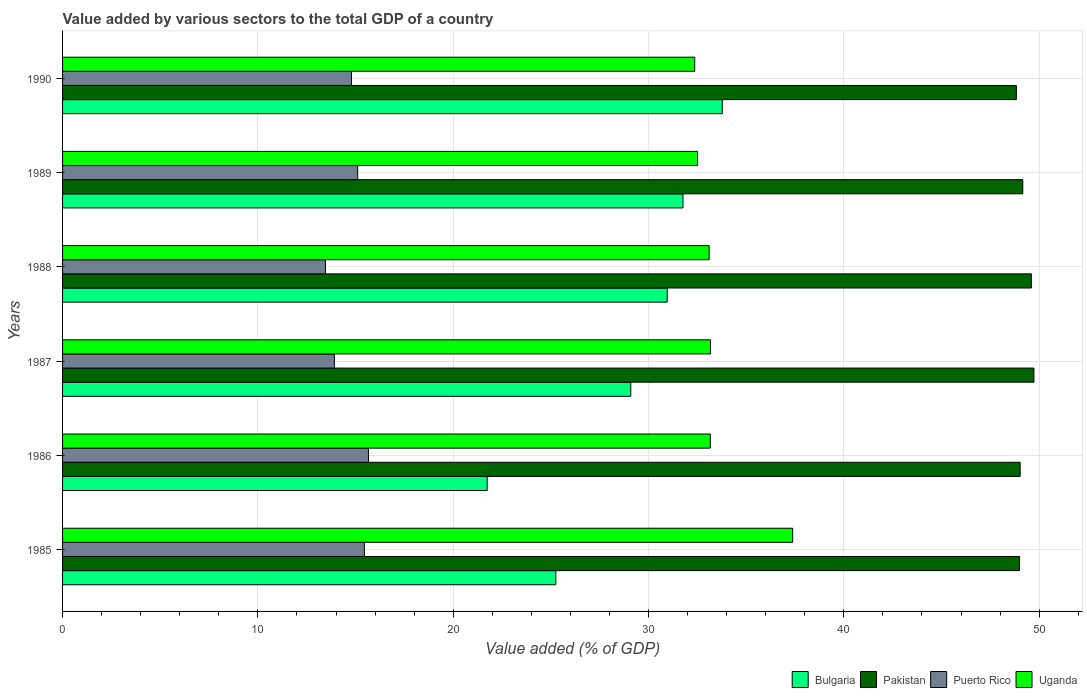How many different coloured bars are there?
Provide a succinct answer. 4. How many groups of bars are there?
Give a very brief answer. 6. Are the number of bars per tick equal to the number of legend labels?
Provide a short and direct response. Yes. Are the number of bars on each tick of the Y-axis equal?
Provide a short and direct response. Yes. How many bars are there on the 3rd tick from the top?
Offer a very short reply. 4. What is the label of the 6th group of bars from the top?
Provide a succinct answer. 1985. What is the value added by various sectors to the total GDP in Bulgaria in 1985?
Keep it short and to the point. 25.25. Across all years, what is the maximum value added by various sectors to the total GDP in Puerto Rico?
Provide a short and direct response. 15.66. Across all years, what is the minimum value added by various sectors to the total GDP in Bulgaria?
Provide a succinct answer. 21.74. In which year was the value added by various sectors to the total GDP in Puerto Rico maximum?
Your answer should be compact. 1986. What is the total value added by various sectors to the total GDP in Uganda in the graph?
Provide a succinct answer. 201.69. What is the difference between the value added by various sectors to the total GDP in Pakistan in 1986 and that in 1990?
Keep it short and to the point. 0.19. What is the difference between the value added by various sectors to the total GDP in Bulgaria in 1990 and the value added by various sectors to the total GDP in Pakistan in 1985?
Provide a succinct answer. -15.22. What is the average value added by various sectors to the total GDP in Pakistan per year?
Your answer should be very brief. 49.22. In the year 1986, what is the difference between the value added by various sectors to the total GDP in Bulgaria and value added by various sectors to the total GDP in Puerto Rico?
Make the answer very short. 6.08. In how many years, is the value added by various sectors to the total GDP in Puerto Rico greater than 26 %?
Provide a short and direct response. 0. What is the ratio of the value added by various sectors to the total GDP in Bulgaria in 1988 to that in 1990?
Provide a succinct answer. 0.92. Is the difference between the value added by various sectors to the total GDP in Bulgaria in 1986 and 1988 greater than the difference between the value added by various sectors to the total GDP in Puerto Rico in 1986 and 1988?
Ensure brevity in your answer.  No. What is the difference between the highest and the second highest value added by various sectors to the total GDP in Puerto Rico?
Offer a terse response. 0.21. What is the difference between the highest and the lowest value added by various sectors to the total GDP in Uganda?
Keep it short and to the point. 5.01. In how many years, is the value added by various sectors to the total GDP in Pakistan greater than the average value added by various sectors to the total GDP in Pakistan taken over all years?
Ensure brevity in your answer.  2. Is it the case that in every year, the sum of the value added by various sectors to the total GDP in Uganda and value added by various sectors to the total GDP in Pakistan is greater than the sum of value added by various sectors to the total GDP in Puerto Rico and value added by various sectors to the total GDP in Bulgaria?
Ensure brevity in your answer.  Yes. What does the 4th bar from the top in 1990 represents?
Your response must be concise. Bulgaria. What does the 2nd bar from the bottom in 1987 represents?
Offer a terse response. Pakistan. Is it the case that in every year, the sum of the value added by various sectors to the total GDP in Bulgaria and value added by various sectors to the total GDP in Uganda is greater than the value added by various sectors to the total GDP in Pakistan?
Provide a short and direct response. Yes. How many bars are there?
Your answer should be very brief. 24. How many years are there in the graph?
Make the answer very short. 6. What is the difference between two consecutive major ticks on the X-axis?
Your answer should be very brief. 10. Are the values on the major ticks of X-axis written in scientific E-notation?
Your answer should be very brief. No. Does the graph contain any zero values?
Your answer should be compact. No. What is the title of the graph?
Your response must be concise. Value added by various sectors to the total GDP of a country. What is the label or title of the X-axis?
Provide a short and direct response. Value added (% of GDP). What is the Value added (% of GDP) of Bulgaria in 1985?
Your answer should be compact. 25.25. What is the Value added (% of GDP) in Pakistan in 1985?
Your answer should be compact. 49. What is the Value added (% of GDP) of Puerto Rico in 1985?
Make the answer very short. 15.45. What is the Value added (% of GDP) in Uganda in 1985?
Your answer should be very brief. 37.38. What is the Value added (% of GDP) in Bulgaria in 1986?
Provide a short and direct response. 21.74. What is the Value added (% of GDP) in Pakistan in 1986?
Your response must be concise. 49.03. What is the Value added (% of GDP) of Puerto Rico in 1986?
Offer a terse response. 15.66. What is the Value added (% of GDP) of Uganda in 1986?
Keep it short and to the point. 33.16. What is the Value added (% of GDP) in Bulgaria in 1987?
Offer a very short reply. 29.09. What is the Value added (% of GDP) in Pakistan in 1987?
Provide a succinct answer. 49.73. What is the Value added (% of GDP) in Puerto Rico in 1987?
Provide a short and direct response. 13.92. What is the Value added (% of GDP) in Uganda in 1987?
Offer a very short reply. 33.17. What is the Value added (% of GDP) in Bulgaria in 1988?
Provide a succinct answer. 30.96. What is the Value added (% of GDP) of Pakistan in 1988?
Ensure brevity in your answer.  49.6. What is the Value added (% of GDP) in Puerto Rico in 1988?
Keep it short and to the point. 13.46. What is the Value added (% of GDP) of Uganda in 1988?
Provide a succinct answer. 33.1. What is the Value added (% of GDP) of Bulgaria in 1989?
Provide a succinct answer. 31.76. What is the Value added (% of GDP) in Pakistan in 1989?
Your response must be concise. 49.16. What is the Value added (% of GDP) of Puerto Rico in 1989?
Make the answer very short. 15.11. What is the Value added (% of GDP) in Uganda in 1989?
Ensure brevity in your answer.  32.51. What is the Value added (% of GDP) in Bulgaria in 1990?
Your response must be concise. 33.78. What is the Value added (% of GDP) in Pakistan in 1990?
Your answer should be very brief. 48.83. What is the Value added (% of GDP) in Puerto Rico in 1990?
Make the answer very short. 14.79. What is the Value added (% of GDP) in Uganda in 1990?
Offer a terse response. 32.36. Across all years, what is the maximum Value added (% of GDP) in Bulgaria?
Keep it short and to the point. 33.78. Across all years, what is the maximum Value added (% of GDP) in Pakistan?
Offer a terse response. 49.73. Across all years, what is the maximum Value added (% of GDP) of Puerto Rico?
Make the answer very short. 15.66. Across all years, what is the maximum Value added (% of GDP) of Uganda?
Your response must be concise. 37.38. Across all years, what is the minimum Value added (% of GDP) of Bulgaria?
Offer a terse response. 21.74. Across all years, what is the minimum Value added (% of GDP) in Pakistan?
Make the answer very short. 48.83. Across all years, what is the minimum Value added (% of GDP) of Puerto Rico?
Offer a terse response. 13.46. Across all years, what is the minimum Value added (% of GDP) of Uganda?
Ensure brevity in your answer.  32.36. What is the total Value added (% of GDP) of Bulgaria in the graph?
Ensure brevity in your answer.  172.59. What is the total Value added (% of GDP) in Pakistan in the graph?
Offer a very short reply. 295.35. What is the total Value added (% of GDP) in Puerto Rico in the graph?
Your answer should be compact. 88.39. What is the total Value added (% of GDP) in Uganda in the graph?
Provide a succinct answer. 201.69. What is the difference between the Value added (% of GDP) in Bulgaria in 1985 and that in 1986?
Your answer should be compact. 3.51. What is the difference between the Value added (% of GDP) of Pakistan in 1985 and that in 1986?
Give a very brief answer. -0.03. What is the difference between the Value added (% of GDP) of Puerto Rico in 1985 and that in 1986?
Keep it short and to the point. -0.21. What is the difference between the Value added (% of GDP) in Uganda in 1985 and that in 1986?
Your response must be concise. 4.22. What is the difference between the Value added (% of GDP) in Bulgaria in 1985 and that in 1987?
Provide a short and direct response. -3.84. What is the difference between the Value added (% of GDP) in Pakistan in 1985 and that in 1987?
Give a very brief answer. -0.74. What is the difference between the Value added (% of GDP) in Puerto Rico in 1985 and that in 1987?
Your response must be concise. 1.54. What is the difference between the Value added (% of GDP) in Uganda in 1985 and that in 1987?
Ensure brevity in your answer.  4.21. What is the difference between the Value added (% of GDP) in Bulgaria in 1985 and that in 1988?
Provide a short and direct response. -5.7. What is the difference between the Value added (% of GDP) of Pakistan in 1985 and that in 1988?
Your response must be concise. -0.61. What is the difference between the Value added (% of GDP) in Puerto Rico in 1985 and that in 1988?
Provide a succinct answer. 1.99. What is the difference between the Value added (% of GDP) in Uganda in 1985 and that in 1988?
Provide a short and direct response. 4.28. What is the difference between the Value added (% of GDP) in Bulgaria in 1985 and that in 1989?
Keep it short and to the point. -6.51. What is the difference between the Value added (% of GDP) of Pakistan in 1985 and that in 1989?
Provide a short and direct response. -0.17. What is the difference between the Value added (% of GDP) in Puerto Rico in 1985 and that in 1989?
Your response must be concise. 0.34. What is the difference between the Value added (% of GDP) of Uganda in 1985 and that in 1989?
Provide a short and direct response. 4.87. What is the difference between the Value added (% of GDP) of Bulgaria in 1985 and that in 1990?
Your response must be concise. -8.52. What is the difference between the Value added (% of GDP) of Pakistan in 1985 and that in 1990?
Offer a very short reply. 0.16. What is the difference between the Value added (% of GDP) in Puerto Rico in 1985 and that in 1990?
Ensure brevity in your answer.  0.66. What is the difference between the Value added (% of GDP) in Uganda in 1985 and that in 1990?
Your response must be concise. 5.01. What is the difference between the Value added (% of GDP) in Bulgaria in 1986 and that in 1987?
Offer a terse response. -7.35. What is the difference between the Value added (% of GDP) in Pakistan in 1986 and that in 1987?
Provide a succinct answer. -0.71. What is the difference between the Value added (% of GDP) in Puerto Rico in 1986 and that in 1987?
Make the answer very short. 1.74. What is the difference between the Value added (% of GDP) in Uganda in 1986 and that in 1987?
Your answer should be compact. -0.01. What is the difference between the Value added (% of GDP) of Bulgaria in 1986 and that in 1988?
Provide a short and direct response. -9.22. What is the difference between the Value added (% of GDP) in Pakistan in 1986 and that in 1988?
Your response must be concise. -0.58. What is the difference between the Value added (% of GDP) of Puerto Rico in 1986 and that in 1988?
Offer a terse response. 2.2. What is the difference between the Value added (% of GDP) in Uganda in 1986 and that in 1988?
Make the answer very short. 0.06. What is the difference between the Value added (% of GDP) in Bulgaria in 1986 and that in 1989?
Ensure brevity in your answer.  -10.02. What is the difference between the Value added (% of GDP) in Pakistan in 1986 and that in 1989?
Provide a succinct answer. -0.13. What is the difference between the Value added (% of GDP) of Puerto Rico in 1986 and that in 1989?
Keep it short and to the point. 0.55. What is the difference between the Value added (% of GDP) of Uganda in 1986 and that in 1989?
Your answer should be compact. 0.65. What is the difference between the Value added (% of GDP) of Bulgaria in 1986 and that in 1990?
Your response must be concise. -12.04. What is the difference between the Value added (% of GDP) in Pakistan in 1986 and that in 1990?
Your answer should be very brief. 0.19. What is the difference between the Value added (% of GDP) of Puerto Rico in 1986 and that in 1990?
Give a very brief answer. 0.87. What is the difference between the Value added (% of GDP) of Uganda in 1986 and that in 1990?
Your answer should be very brief. 0.8. What is the difference between the Value added (% of GDP) of Bulgaria in 1987 and that in 1988?
Your answer should be very brief. -1.87. What is the difference between the Value added (% of GDP) in Pakistan in 1987 and that in 1988?
Ensure brevity in your answer.  0.13. What is the difference between the Value added (% of GDP) in Puerto Rico in 1987 and that in 1988?
Provide a succinct answer. 0.46. What is the difference between the Value added (% of GDP) in Uganda in 1987 and that in 1988?
Offer a terse response. 0.07. What is the difference between the Value added (% of GDP) of Bulgaria in 1987 and that in 1989?
Keep it short and to the point. -2.67. What is the difference between the Value added (% of GDP) of Pakistan in 1987 and that in 1989?
Offer a very short reply. 0.57. What is the difference between the Value added (% of GDP) of Puerto Rico in 1987 and that in 1989?
Give a very brief answer. -1.19. What is the difference between the Value added (% of GDP) of Uganda in 1987 and that in 1989?
Your answer should be very brief. 0.66. What is the difference between the Value added (% of GDP) of Bulgaria in 1987 and that in 1990?
Keep it short and to the point. -4.68. What is the difference between the Value added (% of GDP) in Pakistan in 1987 and that in 1990?
Your answer should be very brief. 0.9. What is the difference between the Value added (% of GDP) in Puerto Rico in 1987 and that in 1990?
Provide a short and direct response. -0.88. What is the difference between the Value added (% of GDP) in Uganda in 1987 and that in 1990?
Your answer should be very brief. 0.8. What is the difference between the Value added (% of GDP) in Bulgaria in 1988 and that in 1989?
Your response must be concise. -0.81. What is the difference between the Value added (% of GDP) in Pakistan in 1988 and that in 1989?
Provide a succinct answer. 0.44. What is the difference between the Value added (% of GDP) in Puerto Rico in 1988 and that in 1989?
Provide a succinct answer. -1.65. What is the difference between the Value added (% of GDP) in Uganda in 1988 and that in 1989?
Offer a very short reply. 0.59. What is the difference between the Value added (% of GDP) of Bulgaria in 1988 and that in 1990?
Your response must be concise. -2.82. What is the difference between the Value added (% of GDP) of Pakistan in 1988 and that in 1990?
Give a very brief answer. 0.77. What is the difference between the Value added (% of GDP) of Puerto Rico in 1988 and that in 1990?
Ensure brevity in your answer.  -1.33. What is the difference between the Value added (% of GDP) in Uganda in 1988 and that in 1990?
Keep it short and to the point. 0.74. What is the difference between the Value added (% of GDP) of Bulgaria in 1989 and that in 1990?
Make the answer very short. -2.01. What is the difference between the Value added (% of GDP) in Pakistan in 1989 and that in 1990?
Ensure brevity in your answer.  0.33. What is the difference between the Value added (% of GDP) in Puerto Rico in 1989 and that in 1990?
Offer a terse response. 0.32. What is the difference between the Value added (% of GDP) of Uganda in 1989 and that in 1990?
Give a very brief answer. 0.15. What is the difference between the Value added (% of GDP) of Bulgaria in 1985 and the Value added (% of GDP) of Pakistan in 1986?
Provide a succinct answer. -23.77. What is the difference between the Value added (% of GDP) in Bulgaria in 1985 and the Value added (% of GDP) in Puerto Rico in 1986?
Ensure brevity in your answer.  9.59. What is the difference between the Value added (% of GDP) in Bulgaria in 1985 and the Value added (% of GDP) in Uganda in 1986?
Your response must be concise. -7.91. What is the difference between the Value added (% of GDP) in Pakistan in 1985 and the Value added (% of GDP) in Puerto Rico in 1986?
Offer a very short reply. 33.34. What is the difference between the Value added (% of GDP) of Pakistan in 1985 and the Value added (% of GDP) of Uganda in 1986?
Offer a terse response. 15.83. What is the difference between the Value added (% of GDP) of Puerto Rico in 1985 and the Value added (% of GDP) of Uganda in 1986?
Offer a very short reply. -17.71. What is the difference between the Value added (% of GDP) in Bulgaria in 1985 and the Value added (% of GDP) in Pakistan in 1987?
Keep it short and to the point. -24.48. What is the difference between the Value added (% of GDP) of Bulgaria in 1985 and the Value added (% of GDP) of Puerto Rico in 1987?
Your answer should be compact. 11.34. What is the difference between the Value added (% of GDP) in Bulgaria in 1985 and the Value added (% of GDP) in Uganda in 1987?
Your answer should be compact. -7.92. What is the difference between the Value added (% of GDP) in Pakistan in 1985 and the Value added (% of GDP) in Puerto Rico in 1987?
Give a very brief answer. 35.08. What is the difference between the Value added (% of GDP) in Pakistan in 1985 and the Value added (% of GDP) in Uganda in 1987?
Provide a short and direct response. 15.83. What is the difference between the Value added (% of GDP) in Puerto Rico in 1985 and the Value added (% of GDP) in Uganda in 1987?
Offer a terse response. -17.72. What is the difference between the Value added (% of GDP) of Bulgaria in 1985 and the Value added (% of GDP) of Pakistan in 1988?
Provide a succinct answer. -24.35. What is the difference between the Value added (% of GDP) in Bulgaria in 1985 and the Value added (% of GDP) in Puerto Rico in 1988?
Make the answer very short. 11.8. What is the difference between the Value added (% of GDP) of Bulgaria in 1985 and the Value added (% of GDP) of Uganda in 1988?
Give a very brief answer. -7.85. What is the difference between the Value added (% of GDP) of Pakistan in 1985 and the Value added (% of GDP) of Puerto Rico in 1988?
Ensure brevity in your answer.  35.54. What is the difference between the Value added (% of GDP) in Pakistan in 1985 and the Value added (% of GDP) in Uganda in 1988?
Give a very brief answer. 15.89. What is the difference between the Value added (% of GDP) of Puerto Rico in 1985 and the Value added (% of GDP) of Uganda in 1988?
Offer a terse response. -17.65. What is the difference between the Value added (% of GDP) of Bulgaria in 1985 and the Value added (% of GDP) of Pakistan in 1989?
Ensure brevity in your answer.  -23.91. What is the difference between the Value added (% of GDP) in Bulgaria in 1985 and the Value added (% of GDP) in Puerto Rico in 1989?
Provide a short and direct response. 10.15. What is the difference between the Value added (% of GDP) of Bulgaria in 1985 and the Value added (% of GDP) of Uganda in 1989?
Your response must be concise. -7.26. What is the difference between the Value added (% of GDP) in Pakistan in 1985 and the Value added (% of GDP) in Puerto Rico in 1989?
Give a very brief answer. 33.89. What is the difference between the Value added (% of GDP) of Pakistan in 1985 and the Value added (% of GDP) of Uganda in 1989?
Your response must be concise. 16.49. What is the difference between the Value added (% of GDP) in Puerto Rico in 1985 and the Value added (% of GDP) in Uganda in 1989?
Provide a succinct answer. -17.06. What is the difference between the Value added (% of GDP) of Bulgaria in 1985 and the Value added (% of GDP) of Pakistan in 1990?
Make the answer very short. -23.58. What is the difference between the Value added (% of GDP) in Bulgaria in 1985 and the Value added (% of GDP) in Puerto Rico in 1990?
Your answer should be compact. 10.46. What is the difference between the Value added (% of GDP) of Bulgaria in 1985 and the Value added (% of GDP) of Uganda in 1990?
Your answer should be compact. -7.11. What is the difference between the Value added (% of GDP) of Pakistan in 1985 and the Value added (% of GDP) of Puerto Rico in 1990?
Offer a terse response. 34.2. What is the difference between the Value added (% of GDP) of Pakistan in 1985 and the Value added (% of GDP) of Uganda in 1990?
Make the answer very short. 16.63. What is the difference between the Value added (% of GDP) of Puerto Rico in 1985 and the Value added (% of GDP) of Uganda in 1990?
Your answer should be compact. -16.91. What is the difference between the Value added (% of GDP) in Bulgaria in 1986 and the Value added (% of GDP) in Pakistan in 1987?
Provide a short and direct response. -27.99. What is the difference between the Value added (% of GDP) in Bulgaria in 1986 and the Value added (% of GDP) in Puerto Rico in 1987?
Your response must be concise. 7.82. What is the difference between the Value added (% of GDP) of Bulgaria in 1986 and the Value added (% of GDP) of Uganda in 1987?
Offer a terse response. -11.43. What is the difference between the Value added (% of GDP) in Pakistan in 1986 and the Value added (% of GDP) in Puerto Rico in 1987?
Offer a terse response. 35.11. What is the difference between the Value added (% of GDP) in Pakistan in 1986 and the Value added (% of GDP) in Uganda in 1987?
Your answer should be compact. 15.86. What is the difference between the Value added (% of GDP) in Puerto Rico in 1986 and the Value added (% of GDP) in Uganda in 1987?
Offer a terse response. -17.51. What is the difference between the Value added (% of GDP) in Bulgaria in 1986 and the Value added (% of GDP) in Pakistan in 1988?
Make the answer very short. -27.86. What is the difference between the Value added (% of GDP) in Bulgaria in 1986 and the Value added (% of GDP) in Puerto Rico in 1988?
Your response must be concise. 8.28. What is the difference between the Value added (% of GDP) of Bulgaria in 1986 and the Value added (% of GDP) of Uganda in 1988?
Your answer should be very brief. -11.36. What is the difference between the Value added (% of GDP) in Pakistan in 1986 and the Value added (% of GDP) in Puerto Rico in 1988?
Make the answer very short. 35.57. What is the difference between the Value added (% of GDP) in Pakistan in 1986 and the Value added (% of GDP) in Uganda in 1988?
Make the answer very short. 15.92. What is the difference between the Value added (% of GDP) of Puerto Rico in 1986 and the Value added (% of GDP) of Uganda in 1988?
Your answer should be compact. -17.44. What is the difference between the Value added (% of GDP) in Bulgaria in 1986 and the Value added (% of GDP) in Pakistan in 1989?
Offer a terse response. -27.42. What is the difference between the Value added (% of GDP) in Bulgaria in 1986 and the Value added (% of GDP) in Puerto Rico in 1989?
Your answer should be compact. 6.63. What is the difference between the Value added (% of GDP) of Bulgaria in 1986 and the Value added (% of GDP) of Uganda in 1989?
Your answer should be very brief. -10.77. What is the difference between the Value added (% of GDP) in Pakistan in 1986 and the Value added (% of GDP) in Puerto Rico in 1989?
Your response must be concise. 33.92. What is the difference between the Value added (% of GDP) of Pakistan in 1986 and the Value added (% of GDP) of Uganda in 1989?
Offer a terse response. 16.52. What is the difference between the Value added (% of GDP) in Puerto Rico in 1986 and the Value added (% of GDP) in Uganda in 1989?
Make the answer very short. -16.85. What is the difference between the Value added (% of GDP) in Bulgaria in 1986 and the Value added (% of GDP) in Pakistan in 1990?
Make the answer very short. -27.09. What is the difference between the Value added (% of GDP) of Bulgaria in 1986 and the Value added (% of GDP) of Puerto Rico in 1990?
Your response must be concise. 6.95. What is the difference between the Value added (% of GDP) in Bulgaria in 1986 and the Value added (% of GDP) in Uganda in 1990?
Give a very brief answer. -10.62. What is the difference between the Value added (% of GDP) of Pakistan in 1986 and the Value added (% of GDP) of Puerto Rico in 1990?
Keep it short and to the point. 34.24. What is the difference between the Value added (% of GDP) in Pakistan in 1986 and the Value added (% of GDP) in Uganda in 1990?
Provide a short and direct response. 16.66. What is the difference between the Value added (% of GDP) in Puerto Rico in 1986 and the Value added (% of GDP) in Uganda in 1990?
Provide a short and direct response. -16.7. What is the difference between the Value added (% of GDP) of Bulgaria in 1987 and the Value added (% of GDP) of Pakistan in 1988?
Keep it short and to the point. -20.51. What is the difference between the Value added (% of GDP) of Bulgaria in 1987 and the Value added (% of GDP) of Puerto Rico in 1988?
Offer a terse response. 15.63. What is the difference between the Value added (% of GDP) in Bulgaria in 1987 and the Value added (% of GDP) in Uganda in 1988?
Offer a very short reply. -4.01. What is the difference between the Value added (% of GDP) in Pakistan in 1987 and the Value added (% of GDP) in Puerto Rico in 1988?
Offer a terse response. 36.27. What is the difference between the Value added (% of GDP) of Pakistan in 1987 and the Value added (% of GDP) of Uganda in 1988?
Provide a succinct answer. 16.63. What is the difference between the Value added (% of GDP) in Puerto Rico in 1987 and the Value added (% of GDP) in Uganda in 1988?
Offer a terse response. -19.19. What is the difference between the Value added (% of GDP) of Bulgaria in 1987 and the Value added (% of GDP) of Pakistan in 1989?
Provide a succinct answer. -20.07. What is the difference between the Value added (% of GDP) of Bulgaria in 1987 and the Value added (% of GDP) of Puerto Rico in 1989?
Your answer should be very brief. 13.98. What is the difference between the Value added (% of GDP) in Bulgaria in 1987 and the Value added (% of GDP) in Uganda in 1989?
Make the answer very short. -3.42. What is the difference between the Value added (% of GDP) of Pakistan in 1987 and the Value added (% of GDP) of Puerto Rico in 1989?
Offer a very short reply. 34.62. What is the difference between the Value added (% of GDP) of Pakistan in 1987 and the Value added (% of GDP) of Uganda in 1989?
Make the answer very short. 17.22. What is the difference between the Value added (% of GDP) in Puerto Rico in 1987 and the Value added (% of GDP) in Uganda in 1989?
Provide a short and direct response. -18.59. What is the difference between the Value added (% of GDP) in Bulgaria in 1987 and the Value added (% of GDP) in Pakistan in 1990?
Provide a succinct answer. -19.74. What is the difference between the Value added (% of GDP) in Bulgaria in 1987 and the Value added (% of GDP) in Puerto Rico in 1990?
Your answer should be compact. 14.3. What is the difference between the Value added (% of GDP) of Bulgaria in 1987 and the Value added (% of GDP) of Uganda in 1990?
Offer a terse response. -3.27. What is the difference between the Value added (% of GDP) of Pakistan in 1987 and the Value added (% of GDP) of Puerto Rico in 1990?
Your response must be concise. 34.94. What is the difference between the Value added (% of GDP) of Pakistan in 1987 and the Value added (% of GDP) of Uganda in 1990?
Keep it short and to the point. 17.37. What is the difference between the Value added (% of GDP) in Puerto Rico in 1987 and the Value added (% of GDP) in Uganda in 1990?
Provide a short and direct response. -18.45. What is the difference between the Value added (% of GDP) of Bulgaria in 1988 and the Value added (% of GDP) of Pakistan in 1989?
Provide a short and direct response. -18.2. What is the difference between the Value added (% of GDP) of Bulgaria in 1988 and the Value added (% of GDP) of Puerto Rico in 1989?
Provide a short and direct response. 15.85. What is the difference between the Value added (% of GDP) of Bulgaria in 1988 and the Value added (% of GDP) of Uganda in 1989?
Provide a succinct answer. -1.55. What is the difference between the Value added (% of GDP) of Pakistan in 1988 and the Value added (% of GDP) of Puerto Rico in 1989?
Offer a very short reply. 34.49. What is the difference between the Value added (% of GDP) of Pakistan in 1988 and the Value added (% of GDP) of Uganda in 1989?
Your response must be concise. 17.09. What is the difference between the Value added (% of GDP) in Puerto Rico in 1988 and the Value added (% of GDP) in Uganda in 1989?
Keep it short and to the point. -19.05. What is the difference between the Value added (% of GDP) in Bulgaria in 1988 and the Value added (% of GDP) in Pakistan in 1990?
Ensure brevity in your answer.  -17.87. What is the difference between the Value added (% of GDP) of Bulgaria in 1988 and the Value added (% of GDP) of Puerto Rico in 1990?
Your answer should be compact. 16.17. What is the difference between the Value added (% of GDP) of Bulgaria in 1988 and the Value added (% of GDP) of Uganda in 1990?
Provide a succinct answer. -1.41. What is the difference between the Value added (% of GDP) of Pakistan in 1988 and the Value added (% of GDP) of Puerto Rico in 1990?
Make the answer very short. 34.81. What is the difference between the Value added (% of GDP) of Pakistan in 1988 and the Value added (% of GDP) of Uganda in 1990?
Provide a succinct answer. 17.24. What is the difference between the Value added (% of GDP) in Puerto Rico in 1988 and the Value added (% of GDP) in Uganda in 1990?
Offer a very short reply. -18.91. What is the difference between the Value added (% of GDP) of Bulgaria in 1989 and the Value added (% of GDP) of Pakistan in 1990?
Your answer should be very brief. -17.07. What is the difference between the Value added (% of GDP) of Bulgaria in 1989 and the Value added (% of GDP) of Puerto Rico in 1990?
Offer a very short reply. 16.97. What is the difference between the Value added (% of GDP) of Pakistan in 1989 and the Value added (% of GDP) of Puerto Rico in 1990?
Give a very brief answer. 34.37. What is the difference between the Value added (% of GDP) of Pakistan in 1989 and the Value added (% of GDP) of Uganda in 1990?
Provide a short and direct response. 16.8. What is the difference between the Value added (% of GDP) in Puerto Rico in 1989 and the Value added (% of GDP) in Uganda in 1990?
Your answer should be compact. -17.26. What is the average Value added (% of GDP) in Bulgaria per year?
Provide a short and direct response. 28.76. What is the average Value added (% of GDP) in Pakistan per year?
Give a very brief answer. 49.22. What is the average Value added (% of GDP) of Puerto Rico per year?
Keep it short and to the point. 14.73. What is the average Value added (% of GDP) of Uganda per year?
Make the answer very short. 33.62. In the year 1985, what is the difference between the Value added (% of GDP) of Bulgaria and Value added (% of GDP) of Pakistan?
Keep it short and to the point. -23.74. In the year 1985, what is the difference between the Value added (% of GDP) of Bulgaria and Value added (% of GDP) of Puerto Rico?
Offer a terse response. 9.8. In the year 1985, what is the difference between the Value added (% of GDP) in Bulgaria and Value added (% of GDP) in Uganda?
Provide a succinct answer. -12.12. In the year 1985, what is the difference between the Value added (% of GDP) in Pakistan and Value added (% of GDP) in Puerto Rico?
Offer a terse response. 33.54. In the year 1985, what is the difference between the Value added (% of GDP) in Pakistan and Value added (% of GDP) in Uganda?
Make the answer very short. 11.62. In the year 1985, what is the difference between the Value added (% of GDP) in Puerto Rico and Value added (% of GDP) in Uganda?
Ensure brevity in your answer.  -21.93. In the year 1986, what is the difference between the Value added (% of GDP) in Bulgaria and Value added (% of GDP) in Pakistan?
Offer a terse response. -27.29. In the year 1986, what is the difference between the Value added (% of GDP) of Bulgaria and Value added (% of GDP) of Puerto Rico?
Give a very brief answer. 6.08. In the year 1986, what is the difference between the Value added (% of GDP) in Bulgaria and Value added (% of GDP) in Uganda?
Provide a succinct answer. -11.42. In the year 1986, what is the difference between the Value added (% of GDP) in Pakistan and Value added (% of GDP) in Puerto Rico?
Give a very brief answer. 33.37. In the year 1986, what is the difference between the Value added (% of GDP) of Pakistan and Value added (% of GDP) of Uganda?
Your answer should be compact. 15.86. In the year 1986, what is the difference between the Value added (% of GDP) in Puerto Rico and Value added (% of GDP) in Uganda?
Offer a very short reply. -17.5. In the year 1987, what is the difference between the Value added (% of GDP) in Bulgaria and Value added (% of GDP) in Pakistan?
Give a very brief answer. -20.64. In the year 1987, what is the difference between the Value added (% of GDP) in Bulgaria and Value added (% of GDP) in Puerto Rico?
Offer a very short reply. 15.18. In the year 1987, what is the difference between the Value added (% of GDP) of Bulgaria and Value added (% of GDP) of Uganda?
Keep it short and to the point. -4.08. In the year 1987, what is the difference between the Value added (% of GDP) in Pakistan and Value added (% of GDP) in Puerto Rico?
Offer a terse response. 35.82. In the year 1987, what is the difference between the Value added (% of GDP) of Pakistan and Value added (% of GDP) of Uganda?
Provide a succinct answer. 16.56. In the year 1987, what is the difference between the Value added (% of GDP) of Puerto Rico and Value added (% of GDP) of Uganda?
Your response must be concise. -19.25. In the year 1988, what is the difference between the Value added (% of GDP) of Bulgaria and Value added (% of GDP) of Pakistan?
Your response must be concise. -18.64. In the year 1988, what is the difference between the Value added (% of GDP) in Bulgaria and Value added (% of GDP) in Puerto Rico?
Your answer should be very brief. 17.5. In the year 1988, what is the difference between the Value added (% of GDP) of Bulgaria and Value added (% of GDP) of Uganda?
Offer a terse response. -2.14. In the year 1988, what is the difference between the Value added (% of GDP) in Pakistan and Value added (% of GDP) in Puerto Rico?
Give a very brief answer. 36.14. In the year 1988, what is the difference between the Value added (% of GDP) in Pakistan and Value added (% of GDP) in Uganda?
Keep it short and to the point. 16.5. In the year 1988, what is the difference between the Value added (% of GDP) of Puerto Rico and Value added (% of GDP) of Uganda?
Your response must be concise. -19.64. In the year 1989, what is the difference between the Value added (% of GDP) of Bulgaria and Value added (% of GDP) of Pakistan?
Provide a short and direct response. -17.4. In the year 1989, what is the difference between the Value added (% of GDP) of Bulgaria and Value added (% of GDP) of Puerto Rico?
Provide a short and direct response. 16.66. In the year 1989, what is the difference between the Value added (% of GDP) in Bulgaria and Value added (% of GDP) in Uganda?
Your response must be concise. -0.75. In the year 1989, what is the difference between the Value added (% of GDP) in Pakistan and Value added (% of GDP) in Puerto Rico?
Give a very brief answer. 34.05. In the year 1989, what is the difference between the Value added (% of GDP) of Pakistan and Value added (% of GDP) of Uganda?
Ensure brevity in your answer.  16.65. In the year 1989, what is the difference between the Value added (% of GDP) in Puerto Rico and Value added (% of GDP) in Uganda?
Offer a very short reply. -17.4. In the year 1990, what is the difference between the Value added (% of GDP) of Bulgaria and Value added (% of GDP) of Pakistan?
Give a very brief answer. -15.06. In the year 1990, what is the difference between the Value added (% of GDP) of Bulgaria and Value added (% of GDP) of Puerto Rico?
Ensure brevity in your answer.  18.99. In the year 1990, what is the difference between the Value added (% of GDP) of Bulgaria and Value added (% of GDP) of Uganda?
Your response must be concise. 1.41. In the year 1990, what is the difference between the Value added (% of GDP) of Pakistan and Value added (% of GDP) of Puerto Rico?
Provide a succinct answer. 34.04. In the year 1990, what is the difference between the Value added (% of GDP) in Pakistan and Value added (% of GDP) in Uganda?
Give a very brief answer. 16.47. In the year 1990, what is the difference between the Value added (% of GDP) in Puerto Rico and Value added (% of GDP) in Uganda?
Your response must be concise. -17.57. What is the ratio of the Value added (% of GDP) of Bulgaria in 1985 to that in 1986?
Your response must be concise. 1.16. What is the ratio of the Value added (% of GDP) in Puerto Rico in 1985 to that in 1986?
Offer a very short reply. 0.99. What is the ratio of the Value added (% of GDP) in Uganda in 1985 to that in 1986?
Your answer should be very brief. 1.13. What is the ratio of the Value added (% of GDP) of Bulgaria in 1985 to that in 1987?
Your answer should be compact. 0.87. What is the ratio of the Value added (% of GDP) of Pakistan in 1985 to that in 1987?
Provide a short and direct response. 0.99. What is the ratio of the Value added (% of GDP) of Puerto Rico in 1985 to that in 1987?
Give a very brief answer. 1.11. What is the ratio of the Value added (% of GDP) of Uganda in 1985 to that in 1987?
Give a very brief answer. 1.13. What is the ratio of the Value added (% of GDP) of Bulgaria in 1985 to that in 1988?
Offer a terse response. 0.82. What is the ratio of the Value added (% of GDP) in Puerto Rico in 1985 to that in 1988?
Make the answer very short. 1.15. What is the ratio of the Value added (% of GDP) of Uganda in 1985 to that in 1988?
Offer a terse response. 1.13. What is the ratio of the Value added (% of GDP) in Bulgaria in 1985 to that in 1989?
Give a very brief answer. 0.8. What is the ratio of the Value added (% of GDP) of Puerto Rico in 1985 to that in 1989?
Give a very brief answer. 1.02. What is the ratio of the Value added (% of GDP) of Uganda in 1985 to that in 1989?
Your answer should be compact. 1.15. What is the ratio of the Value added (% of GDP) in Bulgaria in 1985 to that in 1990?
Make the answer very short. 0.75. What is the ratio of the Value added (% of GDP) in Pakistan in 1985 to that in 1990?
Provide a succinct answer. 1. What is the ratio of the Value added (% of GDP) of Puerto Rico in 1985 to that in 1990?
Keep it short and to the point. 1.04. What is the ratio of the Value added (% of GDP) of Uganda in 1985 to that in 1990?
Ensure brevity in your answer.  1.15. What is the ratio of the Value added (% of GDP) in Bulgaria in 1986 to that in 1987?
Ensure brevity in your answer.  0.75. What is the ratio of the Value added (% of GDP) of Pakistan in 1986 to that in 1987?
Keep it short and to the point. 0.99. What is the ratio of the Value added (% of GDP) in Puerto Rico in 1986 to that in 1987?
Provide a succinct answer. 1.13. What is the ratio of the Value added (% of GDP) in Bulgaria in 1986 to that in 1988?
Make the answer very short. 0.7. What is the ratio of the Value added (% of GDP) of Pakistan in 1986 to that in 1988?
Give a very brief answer. 0.99. What is the ratio of the Value added (% of GDP) of Puerto Rico in 1986 to that in 1988?
Keep it short and to the point. 1.16. What is the ratio of the Value added (% of GDP) of Bulgaria in 1986 to that in 1989?
Ensure brevity in your answer.  0.68. What is the ratio of the Value added (% of GDP) of Pakistan in 1986 to that in 1989?
Your response must be concise. 1. What is the ratio of the Value added (% of GDP) of Puerto Rico in 1986 to that in 1989?
Your answer should be compact. 1.04. What is the ratio of the Value added (% of GDP) in Uganda in 1986 to that in 1989?
Ensure brevity in your answer.  1.02. What is the ratio of the Value added (% of GDP) in Bulgaria in 1986 to that in 1990?
Give a very brief answer. 0.64. What is the ratio of the Value added (% of GDP) in Puerto Rico in 1986 to that in 1990?
Your answer should be compact. 1.06. What is the ratio of the Value added (% of GDP) in Uganda in 1986 to that in 1990?
Ensure brevity in your answer.  1.02. What is the ratio of the Value added (% of GDP) in Bulgaria in 1987 to that in 1988?
Keep it short and to the point. 0.94. What is the ratio of the Value added (% of GDP) in Pakistan in 1987 to that in 1988?
Your answer should be very brief. 1. What is the ratio of the Value added (% of GDP) of Puerto Rico in 1987 to that in 1988?
Ensure brevity in your answer.  1.03. What is the ratio of the Value added (% of GDP) of Bulgaria in 1987 to that in 1989?
Ensure brevity in your answer.  0.92. What is the ratio of the Value added (% of GDP) in Pakistan in 1987 to that in 1989?
Provide a short and direct response. 1.01. What is the ratio of the Value added (% of GDP) of Puerto Rico in 1987 to that in 1989?
Provide a short and direct response. 0.92. What is the ratio of the Value added (% of GDP) in Uganda in 1987 to that in 1989?
Give a very brief answer. 1.02. What is the ratio of the Value added (% of GDP) in Bulgaria in 1987 to that in 1990?
Offer a terse response. 0.86. What is the ratio of the Value added (% of GDP) in Pakistan in 1987 to that in 1990?
Ensure brevity in your answer.  1.02. What is the ratio of the Value added (% of GDP) of Puerto Rico in 1987 to that in 1990?
Ensure brevity in your answer.  0.94. What is the ratio of the Value added (% of GDP) in Uganda in 1987 to that in 1990?
Ensure brevity in your answer.  1.02. What is the ratio of the Value added (% of GDP) of Bulgaria in 1988 to that in 1989?
Keep it short and to the point. 0.97. What is the ratio of the Value added (% of GDP) in Pakistan in 1988 to that in 1989?
Keep it short and to the point. 1.01. What is the ratio of the Value added (% of GDP) of Puerto Rico in 1988 to that in 1989?
Provide a succinct answer. 0.89. What is the ratio of the Value added (% of GDP) of Uganda in 1988 to that in 1989?
Keep it short and to the point. 1.02. What is the ratio of the Value added (% of GDP) of Bulgaria in 1988 to that in 1990?
Offer a terse response. 0.92. What is the ratio of the Value added (% of GDP) of Pakistan in 1988 to that in 1990?
Provide a short and direct response. 1.02. What is the ratio of the Value added (% of GDP) in Puerto Rico in 1988 to that in 1990?
Offer a terse response. 0.91. What is the ratio of the Value added (% of GDP) of Uganda in 1988 to that in 1990?
Keep it short and to the point. 1.02. What is the ratio of the Value added (% of GDP) of Bulgaria in 1989 to that in 1990?
Your answer should be compact. 0.94. What is the ratio of the Value added (% of GDP) in Pakistan in 1989 to that in 1990?
Make the answer very short. 1.01. What is the ratio of the Value added (% of GDP) of Puerto Rico in 1989 to that in 1990?
Keep it short and to the point. 1.02. What is the ratio of the Value added (% of GDP) in Uganda in 1989 to that in 1990?
Your answer should be very brief. 1. What is the difference between the highest and the second highest Value added (% of GDP) in Bulgaria?
Ensure brevity in your answer.  2.01. What is the difference between the highest and the second highest Value added (% of GDP) in Pakistan?
Keep it short and to the point. 0.13. What is the difference between the highest and the second highest Value added (% of GDP) of Puerto Rico?
Ensure brevity in your answer.  0.21. What is the difference between the highest and the second highest Value added (% of GDP) of Uganda?
Offer a terse response. 4.21. What is the difference between the highest and the lowest Value added (% of GDP) in Bulgaria?
Ensure brevity in your answer.  12.04. What is the difference between the highest and the lowest Value added (% of GDP) of Pakistan?
Your response must be concise. 0.9. What is the difference between the highest and the lowest Value added (% of GDP) of Puerto Rico?
Provide a succinct answer. 2.2. What is the difference between the highest and the lowest Value added (% of GDP) in Uganda?
Offer a very short reply. 5.01. 